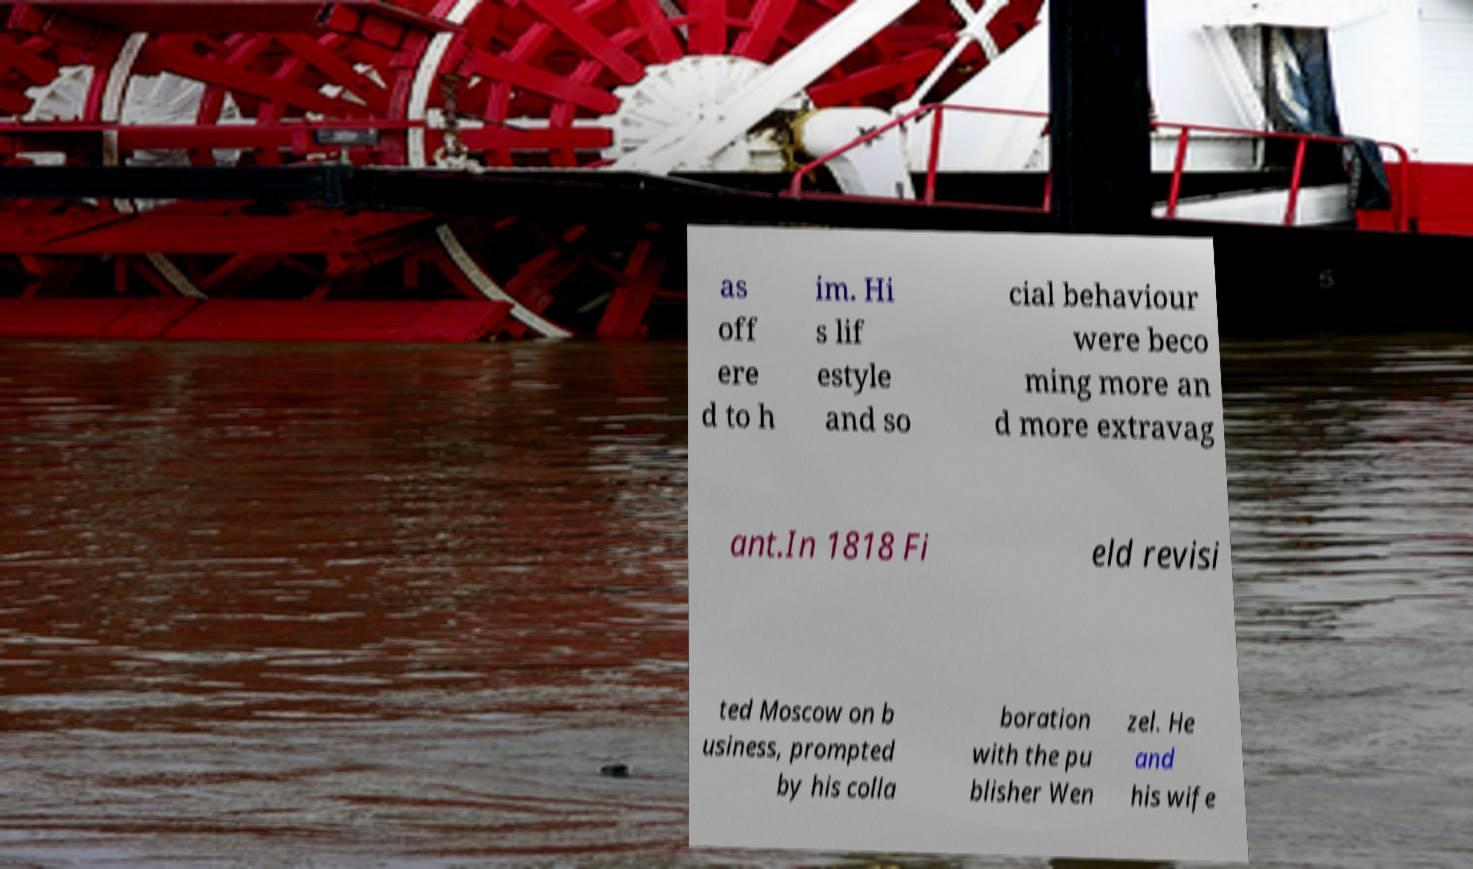Could you assist in decoding the text presented in this image and type it out clearly? as off ere d to h im. Hi s lif estyle and so cial behaviour were beco ming more an d more extravag ant.In 1818 Fi eld revisi ted Moscow on b usiness, prompted by his colla boration with the pu blisher Wen zel. He and his wife 